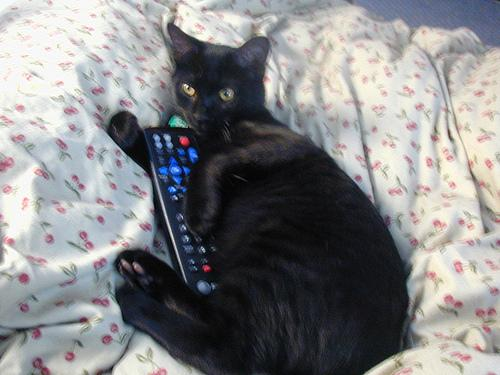What is the cat in control of?

Choices:
A) television
B) car
C) truck
D) radio television 